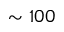<formula> <loc_0><loc_0><loc_500><loc_500>\sim 1 0 0</formula> 